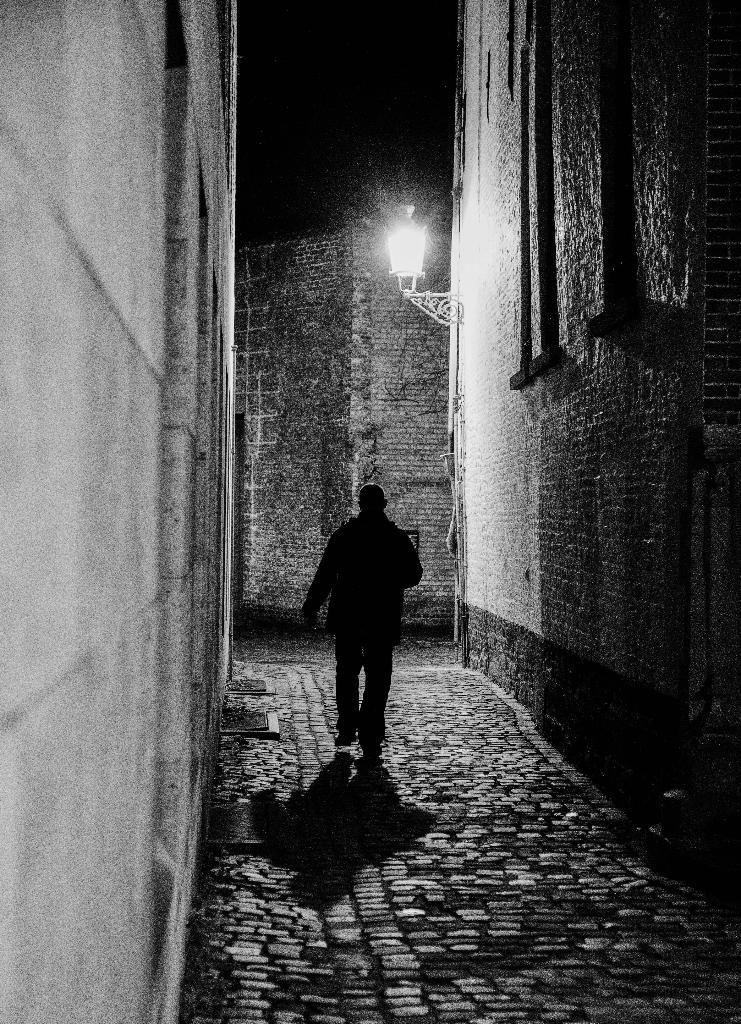What is the man in the image doing? There is a man walking in the lane. What type of surface is the man walking on? Cobbler stones are present on the ground. What can be seen on both sides of the lane? There is a granite wall on both sides of the lane. What is providing light in the image? There is a lamppost in the front. What type of crack can be seen on the man's wrist in the image? There is no man with a wrist or any crack visible in the image. 